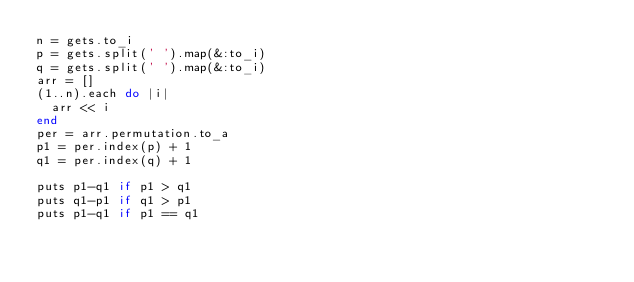<code> <loc_0><loc_0><loc_500><loc_500><_Ruby_>n = gets.to_i
p = gets.split(' ').map(&:to_i)
q = gets.split(' ').map(&:to_i)
arr = []
(1..n).each do |i|
  arr << i
end
per = arr.permutation.to_a
p1 = per.index(p) + 1
q1 = per.index(q) + 1

puts p1-q1 if p1 > q1
puts q1-p1 if q1 > p1
puts p1-q1 if p1 == q1</code> 